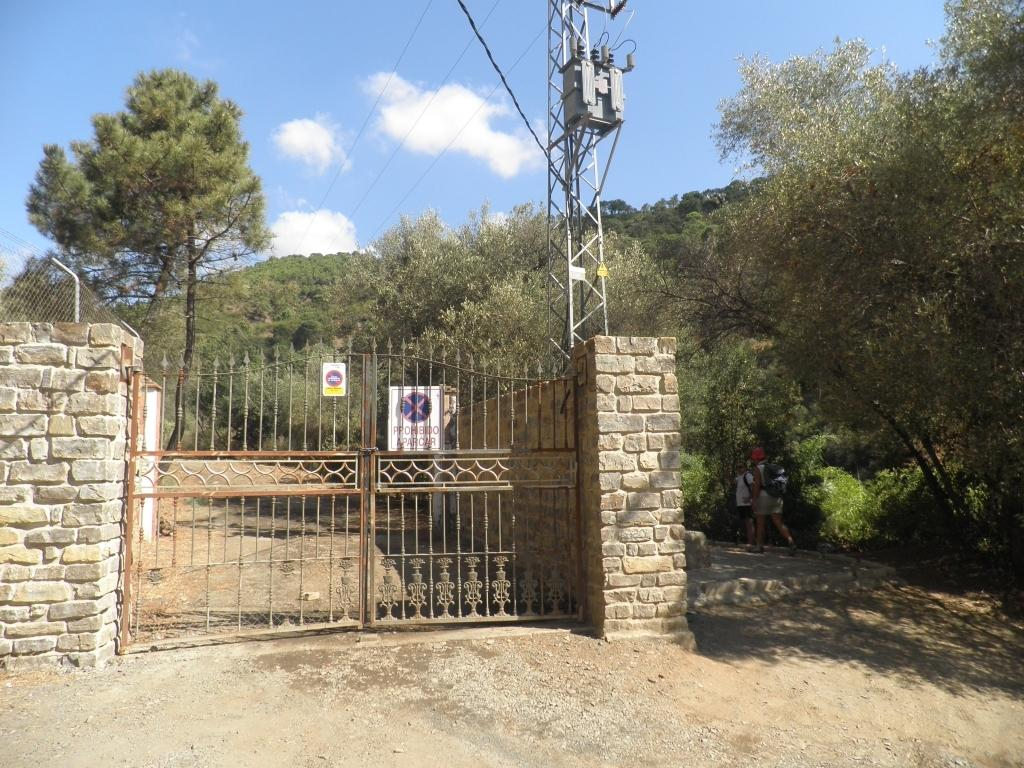What are the people in the image doing? The people in the image are walking on the ground. What structure can be seen attached to a wall in the image? There is a gate attached to a wall in the image. What type of vegetation is present in the image? There are trees in the image. What objects are made of wood in the image? There are boards in the image. What type of communication device is visible in the image? There is an antenna in the image. What is visible in the sky in the image? The sky is visible in the image. How many umbrellas are being used by the people walking in the image? There is no mention of umbrellas in the image; the people are walking without them. What type of curve can be seen in the image? There is no curve mentioned or visible in the image. Are there any yaks present in the image? There is no mention of yaks in the image; they are not present. 